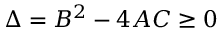<formula> <loc_0><loc_0><loc_500><loc_500>\Delta = B ^ { 2 } - 4 A C \geq 0</formula> 